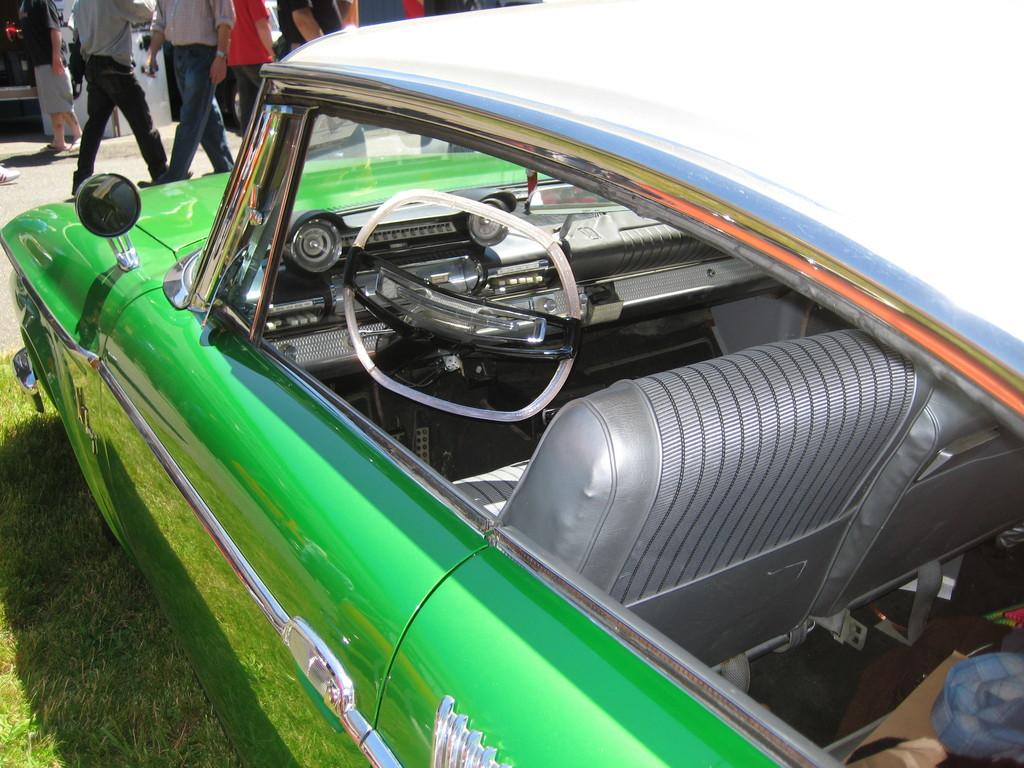What color is the car in the image? The car in the image is green. Where is the car located in the image? The car is parked on the grass. What can be seen in the background of the image? There are people walking on a path in the background of the image. Can the car roll down the hill in the image? The car is parked on the grass and not on a hill, so it cannot roll down a hill in the image. 